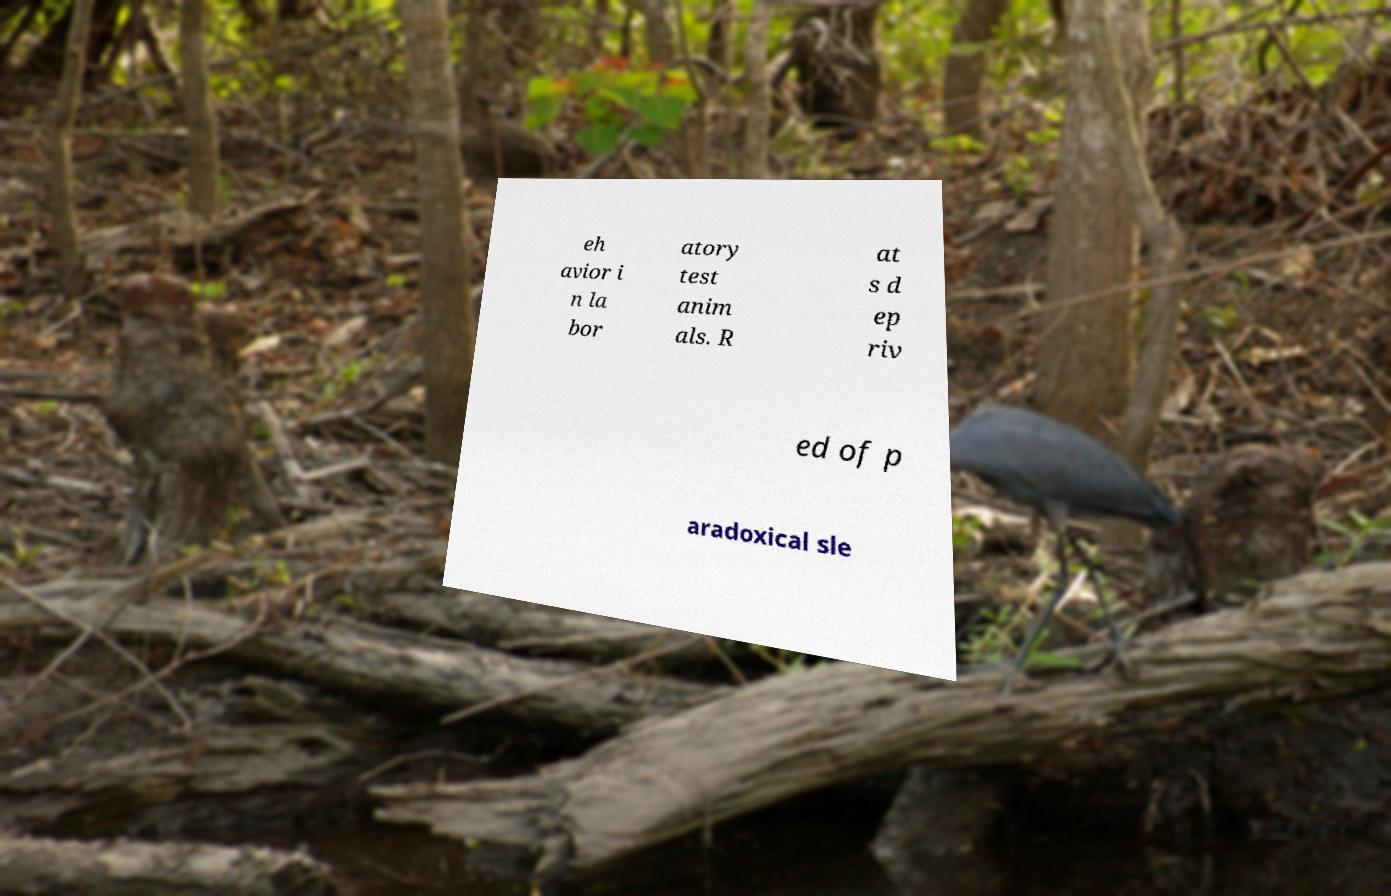Could you extract and type out the text from this image? eh avior i n la bor atory test anim als. R at s d ep riv ed of p aradoxical sle 